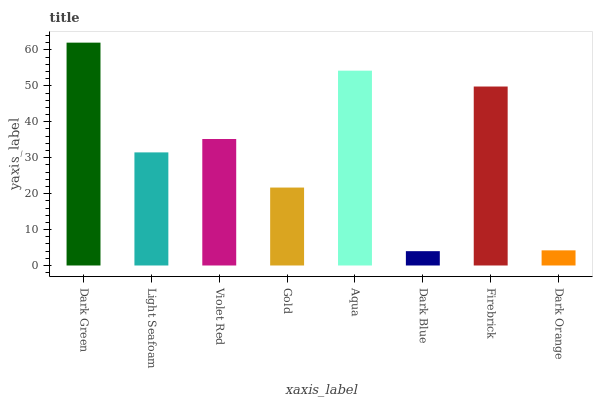Is Dark Blue the minimum?
Answer yes or no. Yes. Is Dark Green the maximum?
Answer yes or no. Yes. Is Light Seafoam the minimum?
Answer yes or no. No. Is Light Seafoam the maximum?
Answer yes or no. No. Is Dark Green greater than Light Seafoam?
Answer yes or no. Yes. Is Light Seafoam less than Dark Green?
Answer yes or no. Yes. Is Light Seafoam greater than Dark Green?
Answer yes or no. No. Is Dark Green less than Light Seafoam?
Answer yes or no. No. Is Violet Red the high median?
Answer yes or no. Yes. Is Light Seafoam the low median?
Answer yes or no. Yes. Is Aqua the high median?
Answer yes or no. No. Is Aqua the low median?
Answer yes or no. No. 